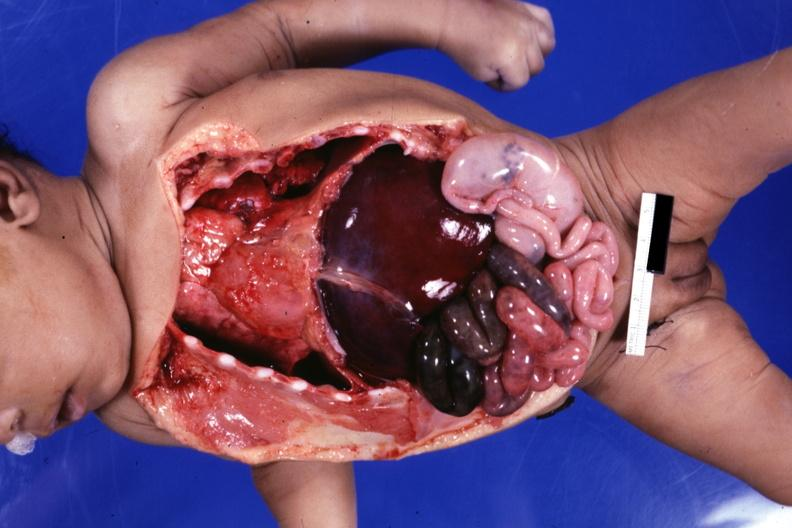s situs inversus present?
Answer the question using a single word or phrase. Yes 